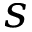<formula> <loc_0><loc_0><loc_500><loc_500>s</formula> 